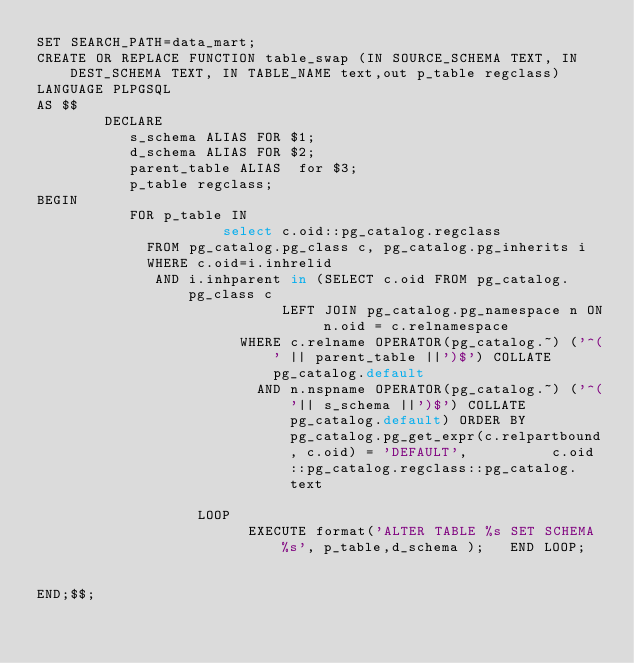<code> <loc_0><loc_0><loc_500><loc_500><_SQL_>SET SEARCH_PATH=data_mart;
CREATE OR REPLACE FUNCTION table_swap (IN SOURCE_SCHEMA TEXT, IN DEST_SCHEMA TEXT, IN TABLE_NAME text,out p_table regclass)
LANGUAGE PLPGSQL
AS $$
        DECLARE
           s_schema ALIAS FOR $1;
           d_schema ALIAS FOR $2;
           parent_table ALIAS  for $3;
           p_table regclass;
BEGIN
           FOR p_table IN
                      select c.oid::pg_catalog.regclass 
						 FROM pg_catalog.pg_class c, pg_catalog.pg_inherits i 
						 WHERE c.oid=i.inhrelid 
							AND i.inhparent in (SELECT c.oid FROM pg_catalog.pg_class c
                             LEFT JOIN pg_catalog.pg_namespace n ON n.oid = c.relnamespace
                        WHERE c.relname OPERATOR(pg_catalog.~) ('^(' || parent_table ||')$') COLLATE pg_catalog.default
                          AND n.nspname OPERATOR(pg_catalog.~) ('^('|| s_schema ||')$') COLLATE pg_catalog.default) ORDER BY pg_catalog.pg_get_expr(c.relpartbound, c.oid) = 'DEFAULT',          c.oid::pg_catalog.regclass::pg_catalog.text

                   LOOP
                         EXECUTE format('ALTER TABLE %s SET SCHEMA %s', p_table,d_schema );   END LOOP;


END;$$;
</code> 